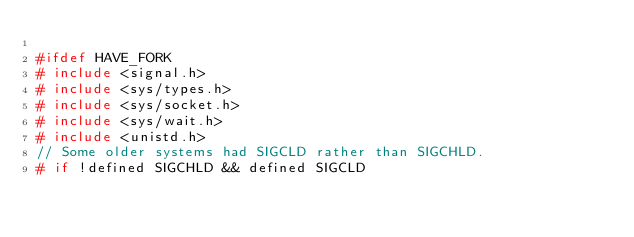<code> <loc_0><loc_0><loc_500><loc_500><_C++_>
#ifdef HAVE_FORK
# include <signal.h>
# include <sys/types.h>
# include <sys/socket.h>
# include <sys/wait.h>
# include <unistd.h>
// Some older systems had SIGCLD rather than SIGCHLD.
# if !defined SIGCHLD && defined SIGCLD</code> 